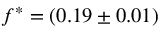<formula> <loc_0><loc_0><loc_500><loc_500>f ^ { \ast } = ( 0 . 1 9 \pm 0 . 0 1 )</formula> 